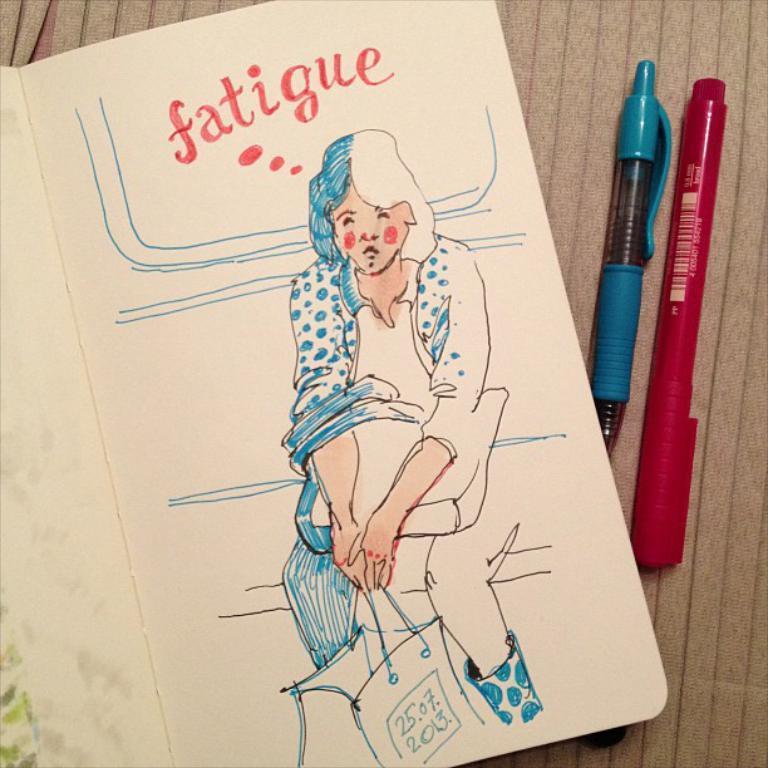Please provide a concise description of this image. In this picture I can see a paper in front, on which there is a drawing of a woman who is holding a bag and I see something is written and on the right side of this picture I can see 2 pens which are of blue and red color. 